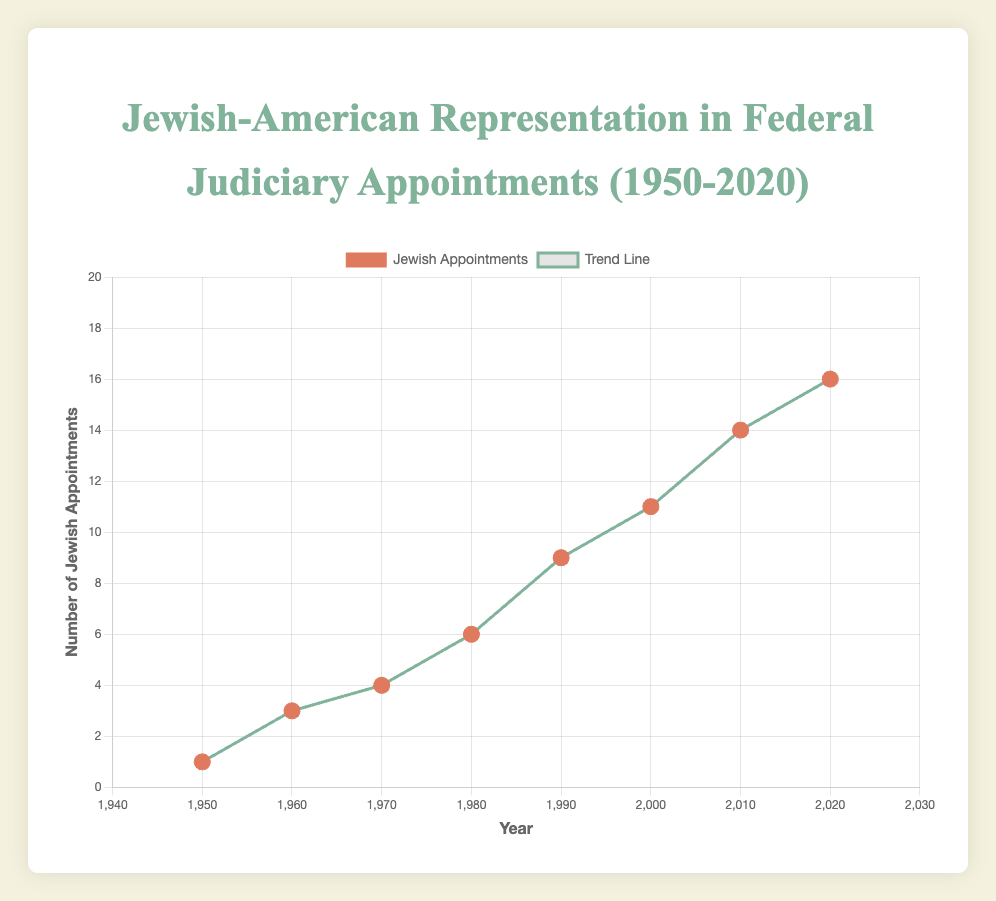What is the title of the chart? Look at the top of the chart where the title is displayed. It reads "Jewish-American Representation in Federal Judiciary Appointments (1950-2020)."
Answer: Jewish-American Representation in Federal Judiciary Appointments (1950-2020) How many data points are in the scatter plot? Count the dots representing data points in the scatter plot. Each dot corresponds to a year's record of Jewish appointments. There are 8 such dots in the plot.
Answer: 8 Which year had the highest number of Jewish appointments, and what is that number? Look at the y-axis to identify the highest data point on the scatter plot. The highest point is at 16 Jewish appointments in the year 2020.
Answer: 2020, 16 How does the trend line compare with the individual data points over the years? Observe the green trend line running through the scatter plot. The trend line shows a positive slope, indicating an overall increase in the number of Jewish appointments over the decades, which is consistent with most individual data points increasing over time.
Answer: Positive slope indicating increase What is the general trend in the number of total appointments from 1950 to 2020? Analyze the scatter plot's trend line, noting the direction and slope. A rising trend line suggests an increase. Based on the data, total appointments generally increased from 30 in 1950 to 65 in 2020.
Answer: Increasing In which decade did the number of Jewish appointments see the largest increase? Compare the Jewish appointment numbers between consecutive decades. The greatest increase is seen from 2000 to 2010, where Jewish appointments rose from 11 to 14.
Answer: 2000 to 2010 What is the ratio of Jewish appointments to total appointments in the year 1980? Divide the number of Jewish appointments by the total appointments for 1980. There were 6 Jewish appointments out of 45 total appointments, resulting in a ratio of 6/45.
Answer: 6/45 Compare the number of Jewish appointments in 1970 and 2010. How much have they increased? Subtract the number of Jewish appointments in 1970 from the number in 2010. There were 4 appointments in 1970 and 14 in 2010, so the increase is 14 - 4.
Answer: 10 What does the color green represent in the chart? Refer to the legend beside the chart. The green color corresponds to the trend line.
Answer: Trend line What is the average number of Jewish appointments per decade from 1950 to 2020? Add up the annual Jewish appointments and divide by the number of decades. The total Jewish appointments are 64 over 8 decades, so the average is 64 / 8.
Answer: 8 